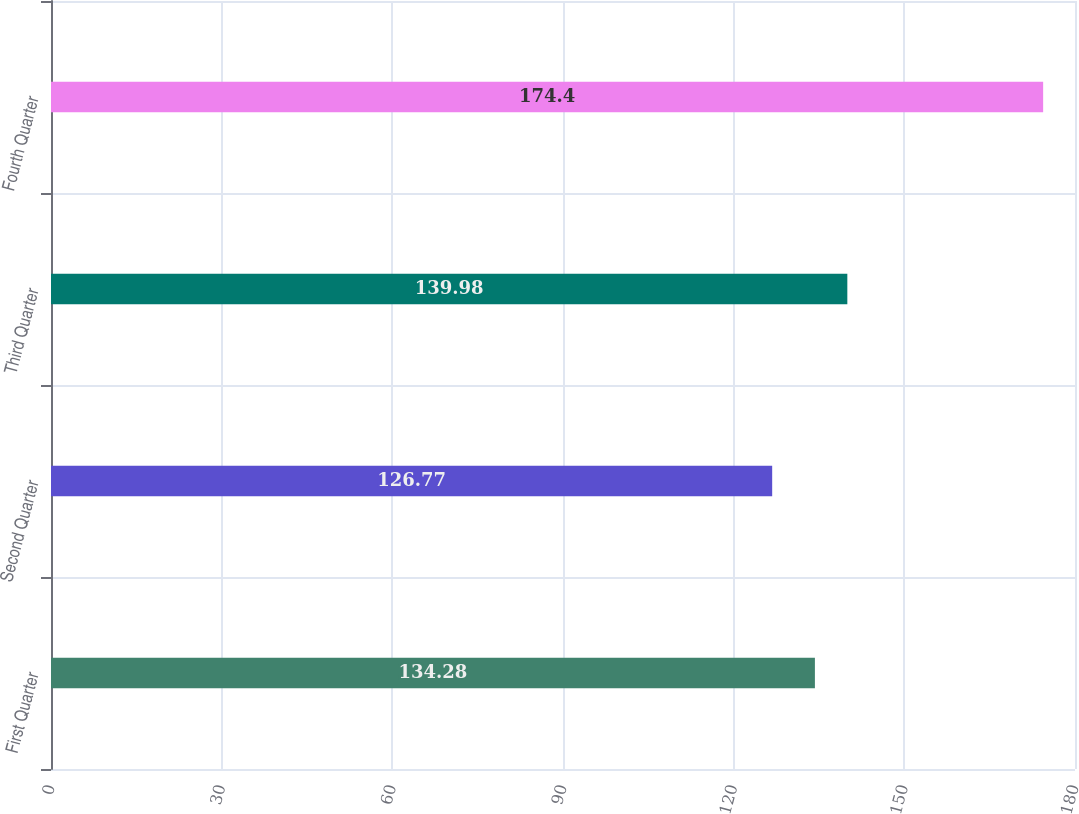Convert chart. <chart><loc_0><loc_0><loc_500><loc_500><bar_chart><fcel>First Quarter<fcel>Second Quarter<fcel>Third Quarter<fcel>Fourth Quarter<nl><fcel>134.28<fcel>126.77<fcel>139.98<fcel>174.4<nl></chart> 